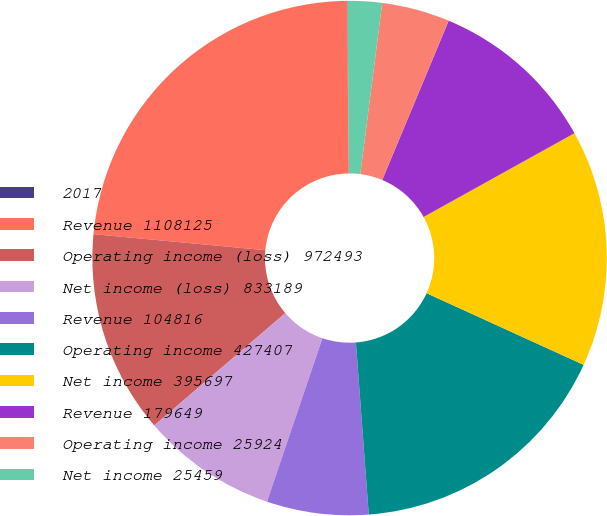Convert chart to OTSL. <chart><loc_0><loc_0><loc_500><loc_500><pie_chart><fcel>2017<fcel>Revenue 1108125<fcel>Operating income (loss) 972493<fcel>Net income (loss) 833189<fcel>Revenue 104816<fcel>Operating income 427407<fcel>Net income 395697<fcel>Revenue 179649<fcel>Operating income 25924<fcel>Net income 25459<nl><fcel>0.03%<fcel>23.36%<fcel>12.76%<fcel>8.52%<fcel>6.39%<fcel>17.0%<fcel>14.88%<fcel>10.64%<fcel>4.27%<fcel>2.15%<nl></chart> 